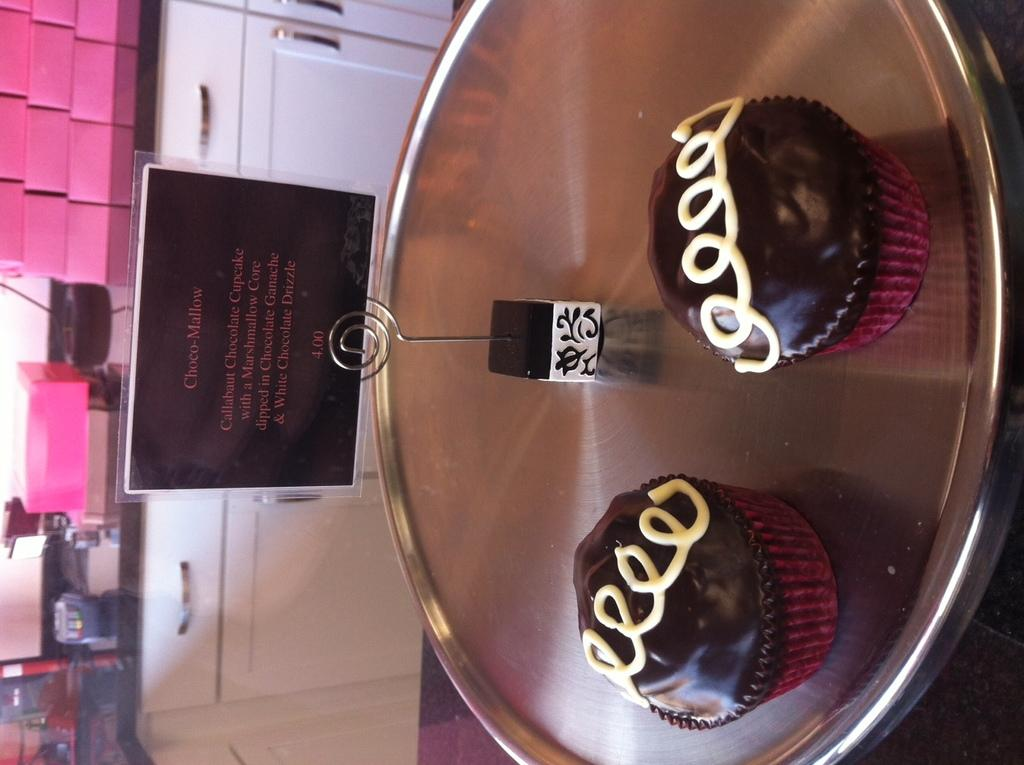<image>
Present a compact description of the photo's key features. Two cupcakes called Choco-Mallow on a silver tray 